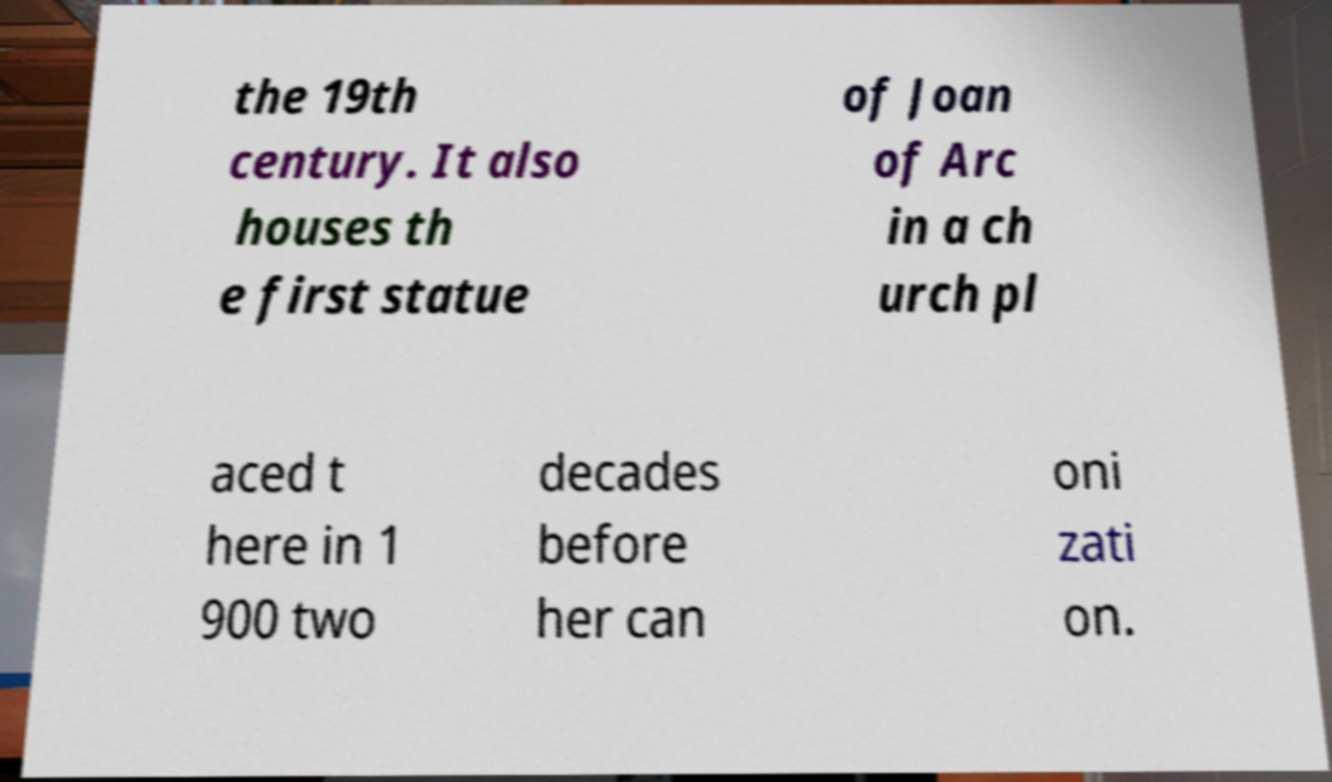Please read and relay the text visible in this image. What does it say? the 19th century. It also houses th e first statue of Joan of Arc in a ch urch pl aced t here in 1 900 two decades before her can oni zati on. 